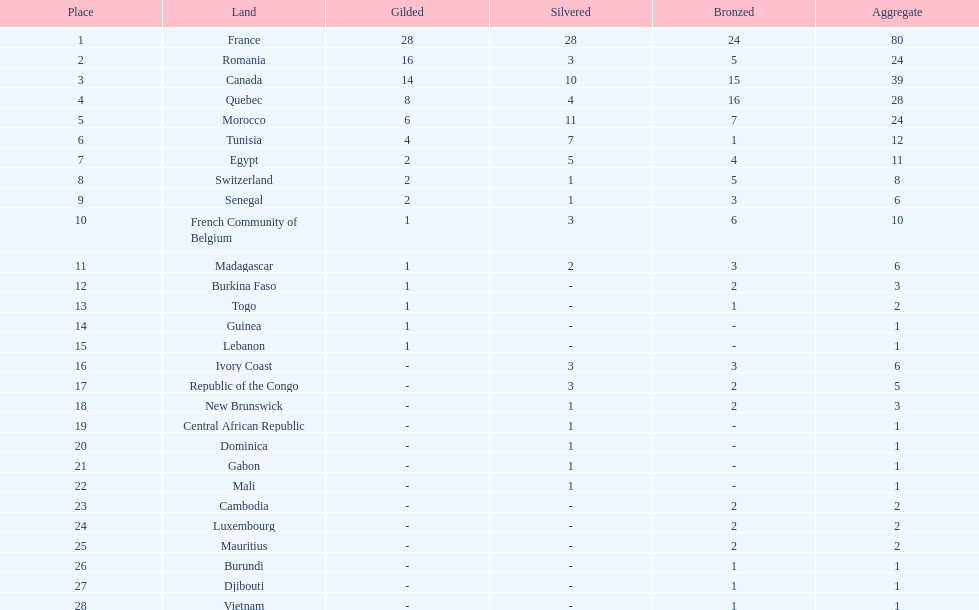How many counties have at least one silver medal? 18. Write the full table. {'header': ['Place', 'Land', 'Gilded', 'Silvered', 'Bronzed', 'Aggregate'], 'rows': [['1', 'France', '28', '28', '24', '80'], ['2', 'Romania', '16', '3', '5', '24'], ['3', 'Canada', '14', '10', '15', '39'], ['4', 'Quebec', '8', '4', '16', '28'], ['5', 'Morocco', '6', '11', '7', '24'], ['6', 'Tunisia', '4', '7', '1', '12'], ['7', 'Egypt', '2', '5', '4', '11'], ['8', 'Switzerland', '2', '1', '5', '8'], ['9', 'Senegal', '2', '1', '3', '6'], ['10', 'French Community of Belgium', '1', '3', '6', '10'], ['11', 'Madagascar', '1', '2', '3', '6'], ['12', 'Burkina Faso', '1', '-', '2', '3'], ['13', 'Togo', '1', '-', '1', '2'], ['14', 'Guinea', '1', '-', '-', '1'], ['15', 'Lebanon', '1', '-', '-', '1'], ['16', 'Ivory Coast', '-', '3', '3', '6'], ['17', 'Republic of the Congo', '-', '3', '2', '5'], ['18', 'New Brunswick', '-', '1', '2', '3'], ['19', 'Central African Republic', '-', '1', '-', '1'], ['20', 'Dominica', '-', '1', '-', '1'], ['21', 'Gabon', '-', '1', '-', '1'], ['22', 'Mali', '-', '1', '-', '1'], ['23', 'Cambodia', '-', '-', '2', '2'], ['24', 'Luxembourg', '-', '-', '2', '2'], ['25', 'Mauritius', '-', '-', '2', '2'], ['26', 'Burundi', '-', '-', '1', '1'], ['27', 'Djibouti', '-', '-', '1', '1'], ['28', 'Vietnam', '-', '-', '1', '1']]} 